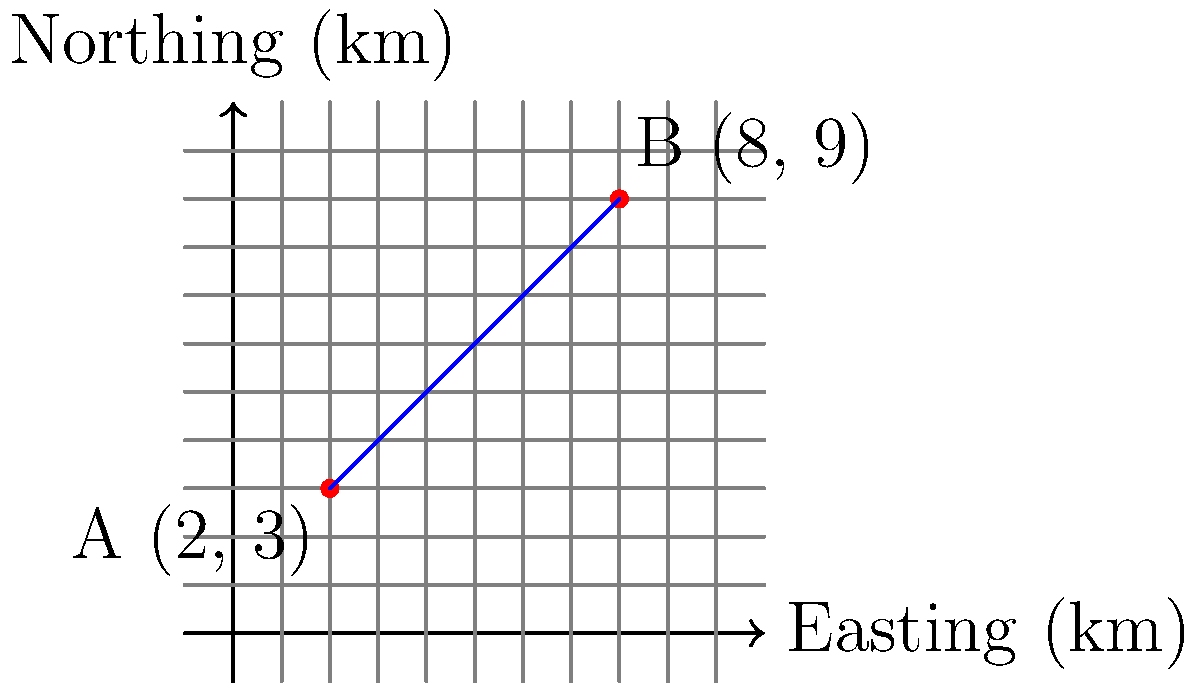As a homeschooling mother teaching your children about coordinate geometry while hiking in Hobbs State Park, you come across a trail map. The map shows two points on a hiking trail: Point A (2 km East, 3 km North) and Point B (8 km East, 9 km North). Calculate the slope of this section of the trail. To calculate the slope of the trail section, we'll use the slope formula:

$$ \text{Slope} = \frac{\text{Rise}}{\text{Run}} = \frac{y_2 - y_1}{x_2 - x_1} $$

Where $(x_1, y_1)$ is the first point and $(x_2, y_2)$ is the second point.

Step 1: Identify the coordinates
Point A: $(x_1, y_1) = (2, 3)$
Point B: $(x_2, y_2) = (8, 9)$

Step 2: Calculate the rise (change in y)
Rise $= y_2 - y_1 = 9 - 3 = 6$ km

Step 3: Calculate the run (change in x)
Run $= x_2 - x_1 = 8 - 2 = 6$ km

Step 4: Apply the slope formula
$$ \text{Slope} = \frac{\text{Rise}}{\text{Run}} = \frac{6}{6} = 1 $$

Therefore, the slope of this section of the trail is 1, which means for every 1 km traveled horizontally, the trail rises 1 km vertically.
Answer: $1$ 